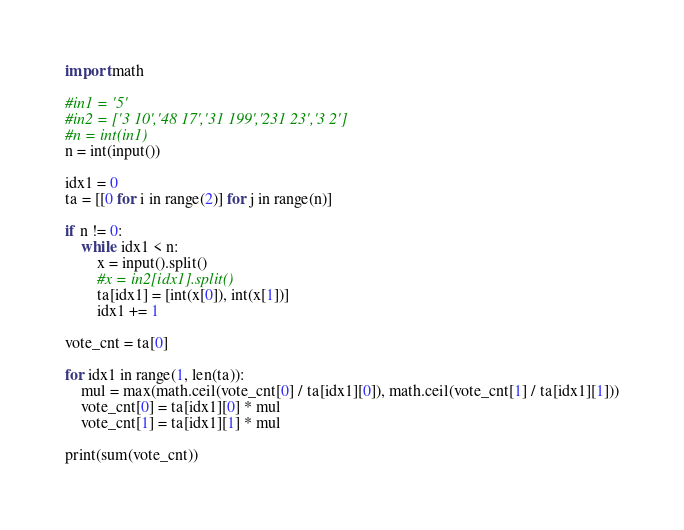<code> <loc_0><loc_0><loc_500><loc_500><_Python_>import math

#in1 = '5'
#in2 = ['3 10','48 17','31 199','231 23','3 2']
#n = int(in1)
n = int(input())

idx1 = 0
ta = [[0 for i in range(2)] for j in range(n)]

if n != 0:
    while idx1 < n:
        x = input().split()
        #x = in2[idx1].split()
        ta[idx1] = [int(x[0]), int(x[1])]
        idx1 += 1

vote_cnt = ta[0]

for idx1 in range(1, len(ta)):
    mul = max(math.ceil(vote_cnt[0] / ta[idx1][0]), math.ceil(vote_cnt[1] / ta[idx1][1]))
    vote_cnt[0] = ta[idx1][0] * mul
    vote_cnt[1] = ta[idx1][1] * mul

print(sum(vote_cnt))
</code> 